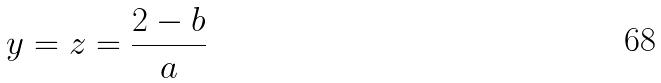Convert formula to latex. <formula><loc_0><loc_0><loc_500><loc_500>y = z = \frac { 2 - b } { a }</formula> 